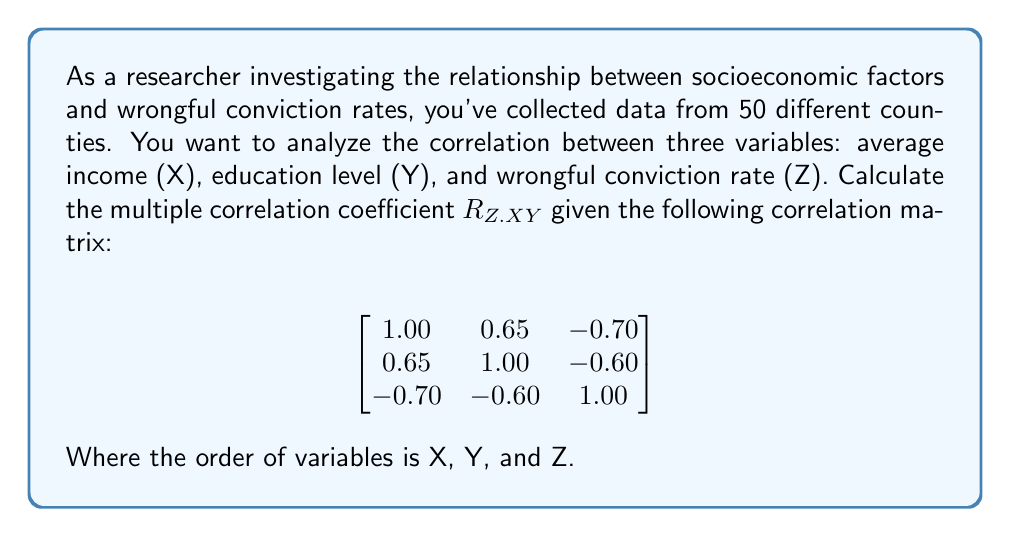Teach me how to tackle this problem. To calculate the multiple correlation coefficient $R_{Z.XY}$, we need to use the following formula:

$$R_{Z.XY} = \sqrt{1 - \frac{1 - r_{ZX}^2 - r_{ZY}^2 + 2r_{ZX}r_{ZY}r_{XY}}{1 - r_{XY}^2}}$$

Where:
$r_{ZX}$ is the correlation between Z and X
$r_{ZY}$ is the correlation between Z and Y
$r_{XY}$ is the correlation between X and Y

From the given correlation matrix:
$r_{ZX} = -0.70$
$r_{ZY} = -0.60$
$r_{XY} = 0.65$

Let's substitute these values into the formula:

$$R_{Z.XY} = \sqrt{1 - \frac{1 - (-0.70)^2 - (-0.60)^2 + 2(-0.70)(-0.60)(0.65)}{1 - (0.65)^2}}$$

Now, let's solve step by step:

1) First, calculate the numerator inside the fraction:
   $1 - (-0.70)^2 - (-0.60)^2 + 2(-0.70)(-0.60)(0.65)$
   $= 1 - 0.49 - 0.36 + 2(0.42)(0.65)$
   $= 1 - 0.49 - 0.36 + 0.546$
   $= 0.696$

2) Calculate the denominator:
   $1 - (0.65)^2 = 1 - 0.4225 = 0.5775$

3) Now, we have:
   $$R_{Z.XY} = \sqrt{1 - \frac{0.696}{0.5775}}$$

4) Simplify:
   $$R_{Z.XY} = \sqrt{1 - 1.2052} = \sqrt{-0.2052}$$

5) Take the square root:
   $$R_{Z.XY} = 0.4531$$

Therefore, the multiple correlation coefficient $R_{Z.XY}$ is approximately 0.4531.
Answer: $R_{Z.XY} \approx 0.4531$ 